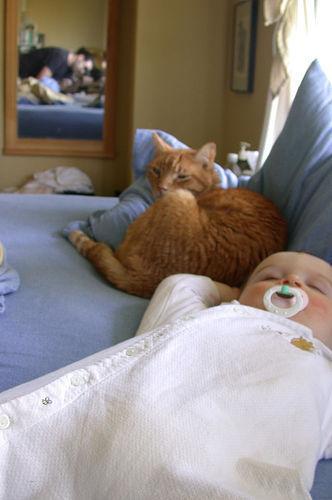How many babies are there?
Give a very brief answer. 1. 